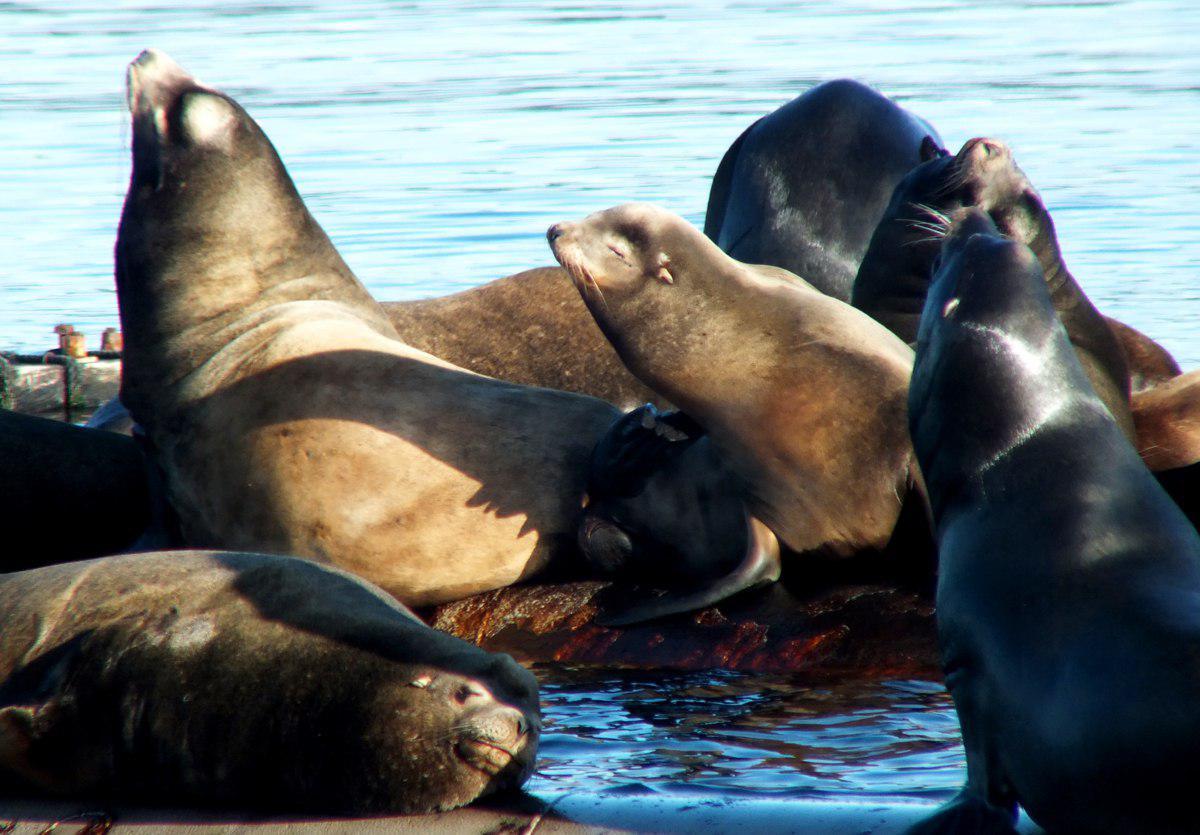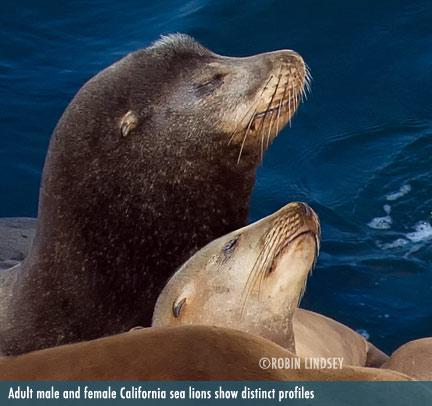The first image is the image on the left, the second image is the image on the right. Assess this claim about the two images: "One image has no more than three seals laying on rocks.". Correct or not? Answer yes or no. No. The first image is the image on the left, the second image is the image on the right. For the images displayed, is the sentence "In at least one image there are seals laying on a wooden dock" factually correct? Answer yes or no. No. 